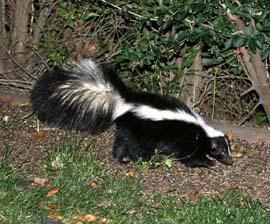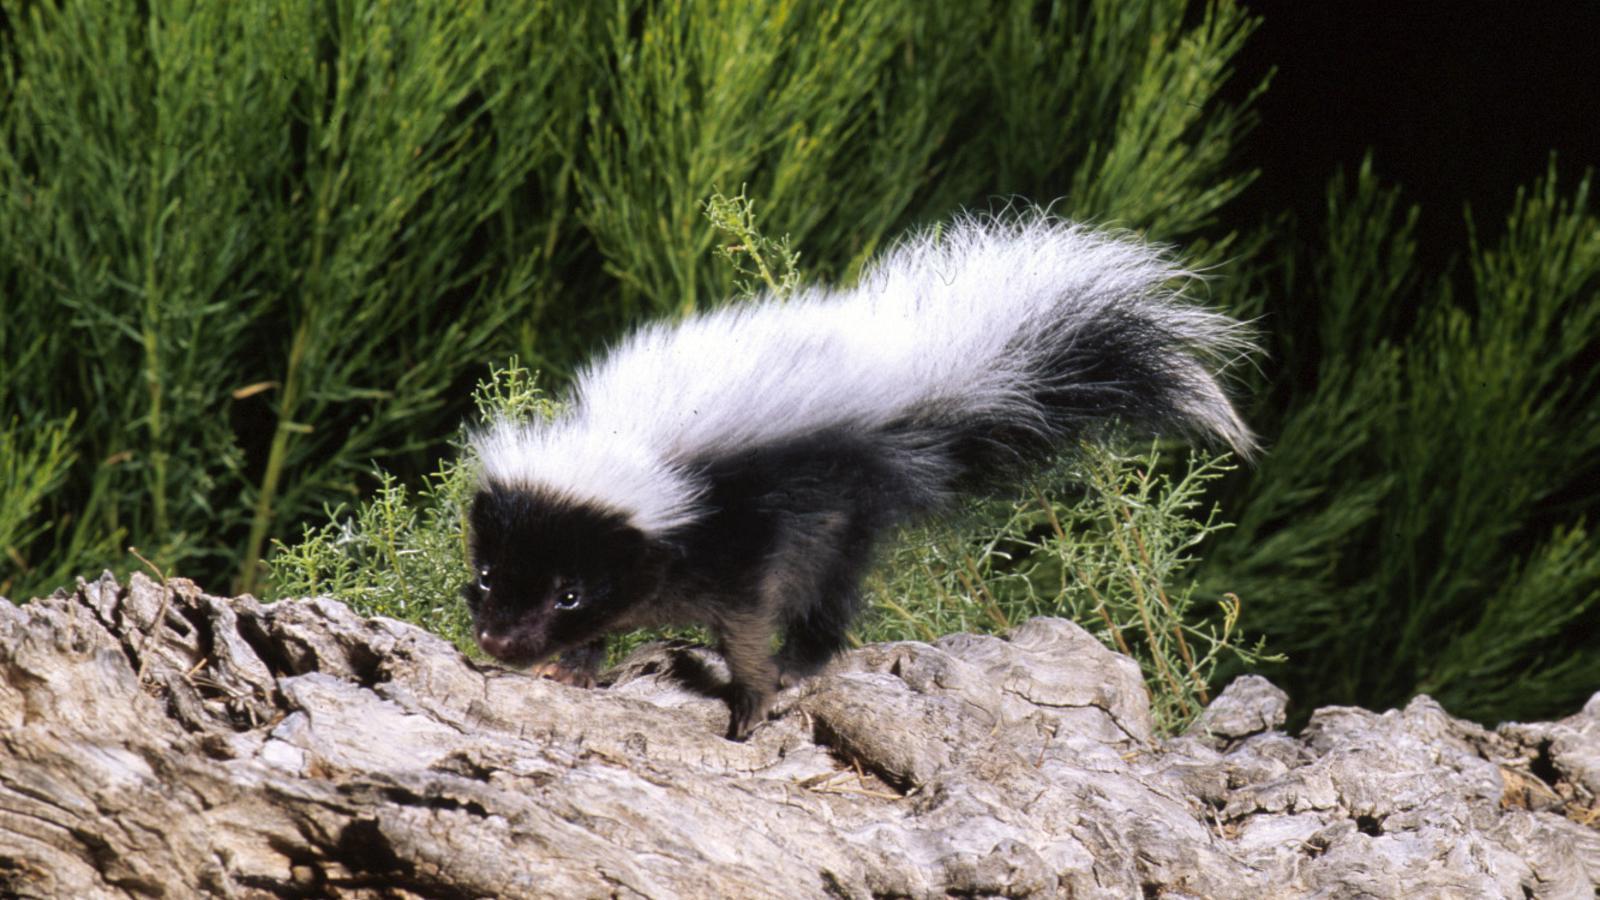The first image is the image on the left, the second image is the image on the right. Analyze the images presented: Is the assertion "There are two skunks that are positioned in a similar direction." valid? Answer yes or no. No. The first image is the image on the left, the second image is the image on the right. Considering the images on both sides, is "Each image contains exactly one skunk, which is on all fours with its body turned rightward." valid? Answer yes or no. No. 